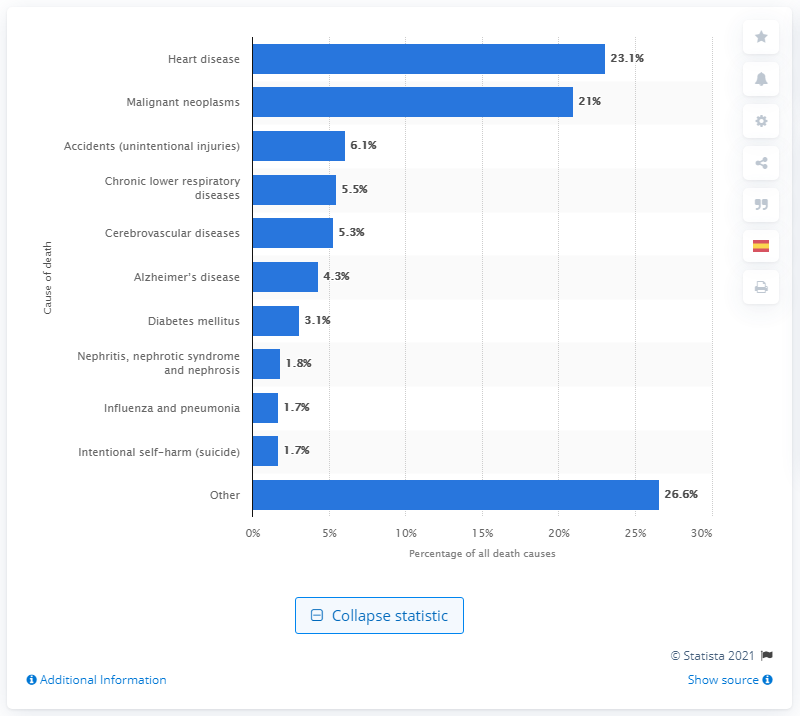Indicate a few pertinent items in this graphic. According to data, heart disease is responsible for approximately 23.1% of all deaths in the United States. In the United States, heart disease is the leading cause of death. 